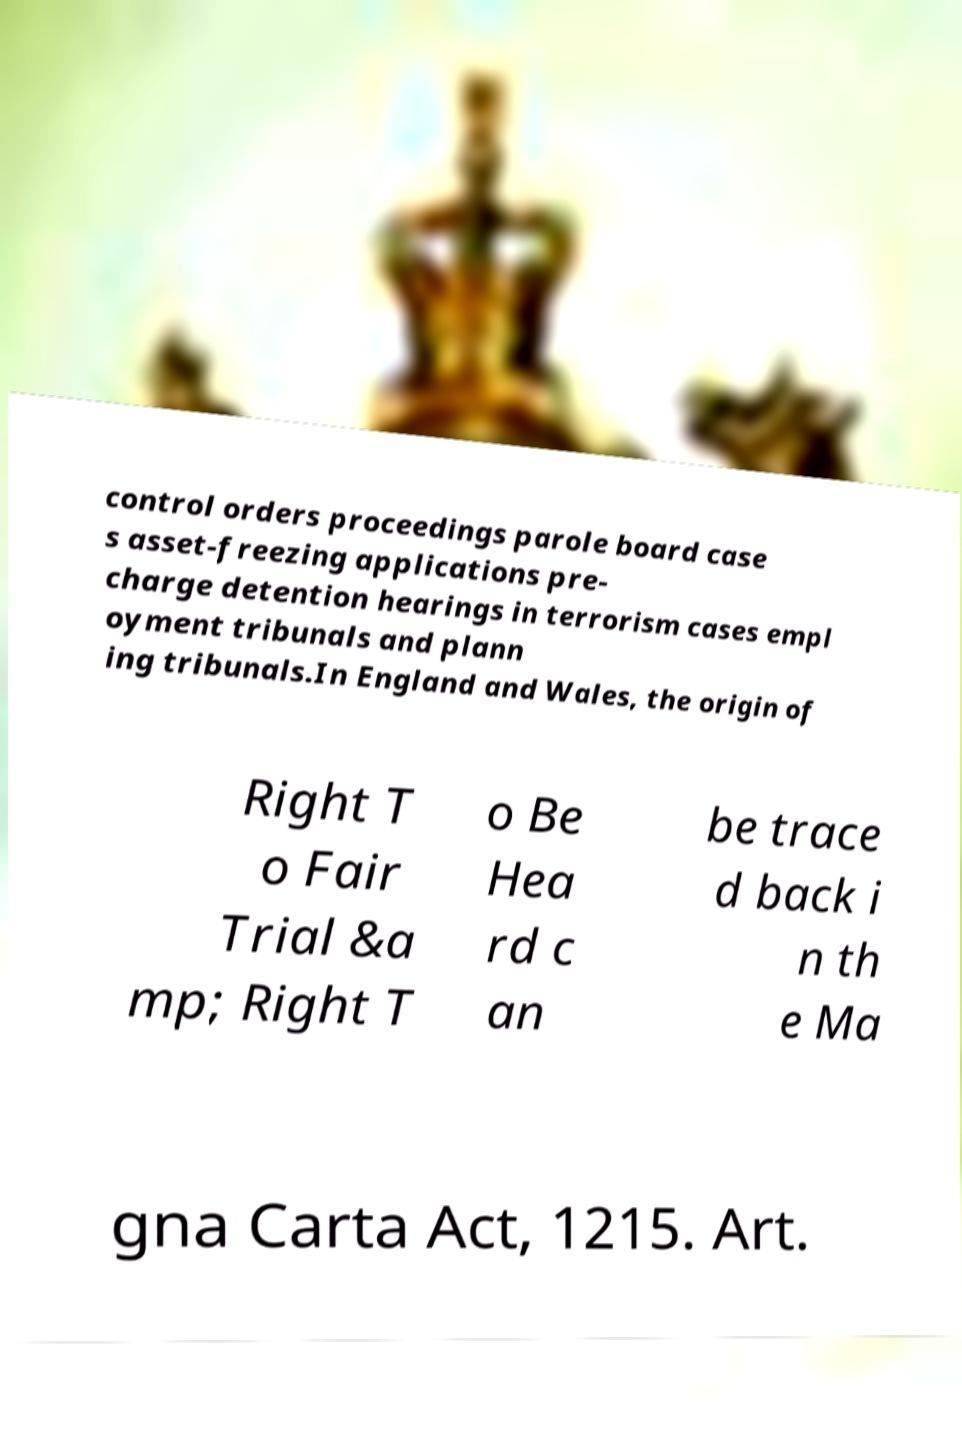Can you accurately transcribe the text from the provided image for me? control orders proceedings parole board case s asset-freezing applications pre- charge detention hearings in terrorism cases empl oyment tribunals and plann ing tribunals.In England and Wales, the origin of Right T o Fair Trial &a mp; Right T o Be Hea rd c an be trace d back i n th e Ma gna Carta Act, 1215. Art. 